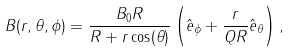Convert formula to latex. <formula><loc_0><loc_0><loc_500><loc_500>B ( r , \theta , \phi ) = \frac { B _ { 0 } R } { R + r \cos ( \theta ) } \left ( \hat { e } _ { \phi } + \frac { r } { Q R } \hat { e } _ { \theta } \right ) ,</formula> 